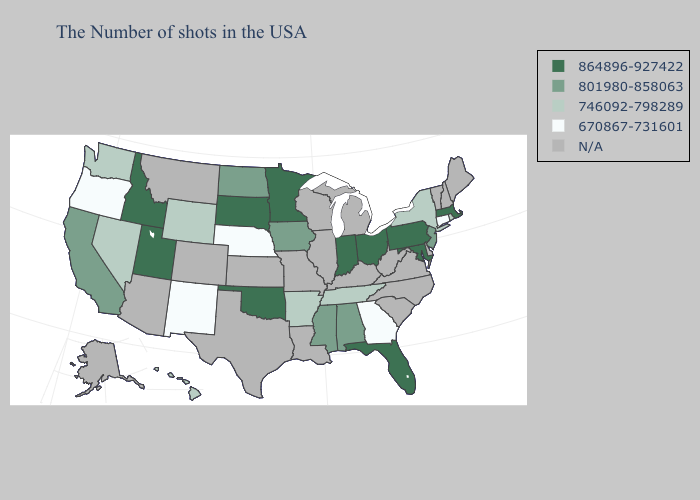Name the states that have a value in the range N/A?
Quick response, please. Maine, New Hampshire, Vermont, Delaware, Virginia, North Carolina, South Carolina, West Virginia, Michigan, Kentucky, Wisconsin, Illinois, Louisiana, Missouri, Kansas, Texas, Colorado, Montana, Arizona, Alaska. What is the highest value in states that border Montana?
Be succinct. 864896-927422. Among the states that border California , does Oregon have the highest value?
Short answer required. No. Name the states that have a value in the range 801980-858063?
Short answer required. New Jersey, Alabama, Mississippi, Iowa, North Dakota, California. Which states have the lowest value in the USA?
Be succinct. Connecticut, Georgia, Nebraska, New Mexico, Oregon. What is the highest value in the South ?
Write a very short answer. 864896-927422. Which states have the lowest value in the West?
Keep it brief. New Mexico, Oregon. What is the value of Kansas?
Quick response, please. N/A. What is the lowest value in states that border South Dakota?
Keep it brief. 670867-731601. Which states hav the highest value in the South?
Quick response, please. Maryland, Florida, Oklahoma. Which states have the lowest value in the USA?
Quick response, please. Connecticut, Georgia, Nebraska, New Mexico, Oregon. Among the states that border Utah , does New Mexico have the lowest value?
Be succinct. Yes. 